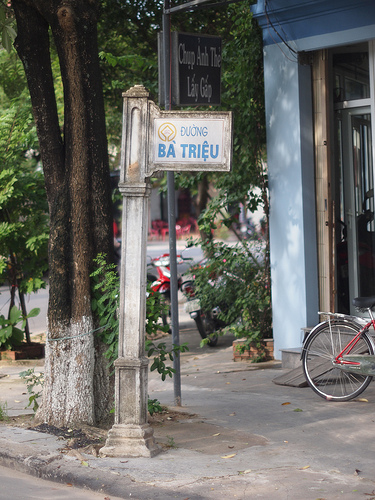Please provide the bounding box coordinate of the region this sentence describes: A sign post on the roadside. The coordinates for the bounding box around the region described as 'a sign post on the roadside' are approximately [0.43, 0.21, 0.6, 0.33]. 